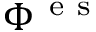<formula> <loc_0><loc_0><loc_500><loc_500>\Phi ^ { e s }</formula> 